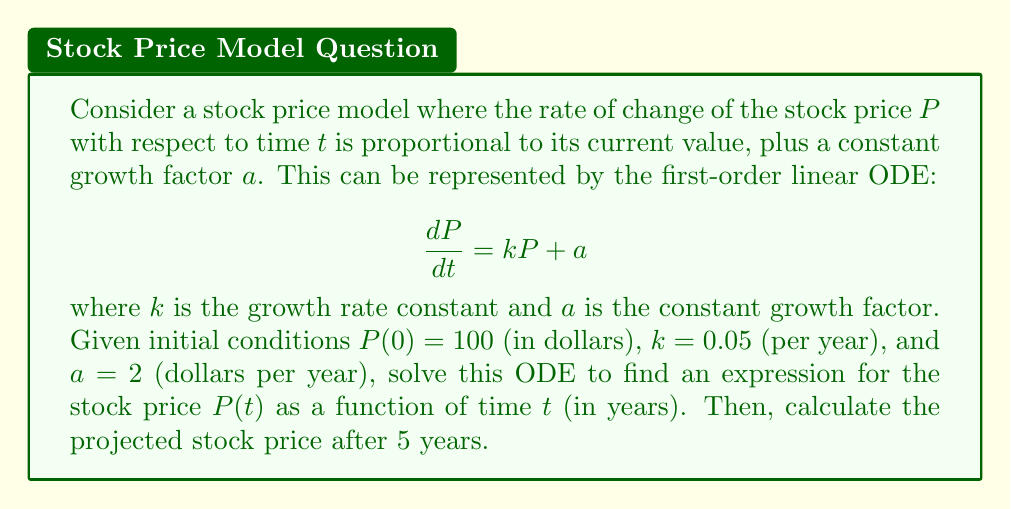Teach me how to tackle this problem. To solve this first-order linear ODE, we'll follow these steps:

1) First, we recognize this as a non-homogeneous linear ODE of the form:

   $$\frac{dP}{dt} + (-k)P = a$$

2) The general solution for this type of ODE is:

   $$P(t) = e^{kt}(C + \int a e^{-kt} dt)$$

   where $C$ is a constant of integration.

3) Evaluating the integral:

   $$\int a e^{-kt} dt = -\frac{a}{k}e^{-kt} + D$$

   where $D$ is another constant.

4) Substituting back:

   $$P(t) = e^{kt}(C - \frac{a}{k}e^{-kt} + D) = Ce^{kt} - \frac{a}{k} + De^{kt}$$

5) Combining the constants:

   $$P(t) = Ae^{kt} - \frac{a}{k}$$

   where $A = C + D$.

6) Using the initial condition $P(0) = 100$:

   $$100 = A - \frac{a}{k}$$
   $$A = 100 + \frac{a}{k} = 100 + \frac{2}{0.05} = 140$$

7) Therefore, the particular solution is:

   $$P(t) = 140e^{0.05t} - \frac{2}{0.05} = 140e^{0.05t} - 40$$

8) To find the price after 5 years, we evaluate $P(5)$:

   $$P(5) = 140e^{0.05(5)} - 40 = 140e^{0.25} - 40 \approx 179.07$$
Answer: The expression for the stock price as a function of time is:

$$P(t) = 140e^{0.05t} - 40$$

The projected stock price after 5 years is approximately $179.07. 